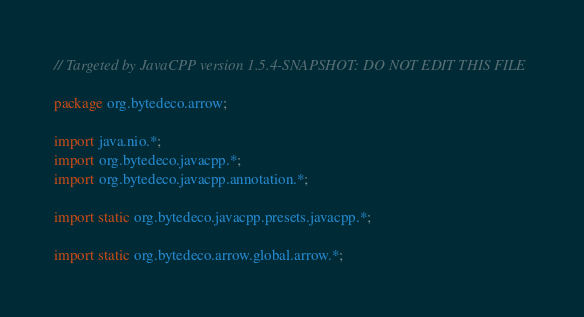<code> <loc_0><loc_0><loc_500><loc_500><_Java_>// Targeted by JavaCPP version 1.5.4-SNAPSHOT: DO NOT EDIT THIS FILE

package org.bytedeco.arrow;

import java.nio.*;
import org.bytedeco.javacpp.*;
import org.bytedeco.javacpp.annotation.*;

import static org.bytedeco.javacpp.presets.javacpp.*;

import static org.bytedeco.arrow.global.arrow.*;

</code> 